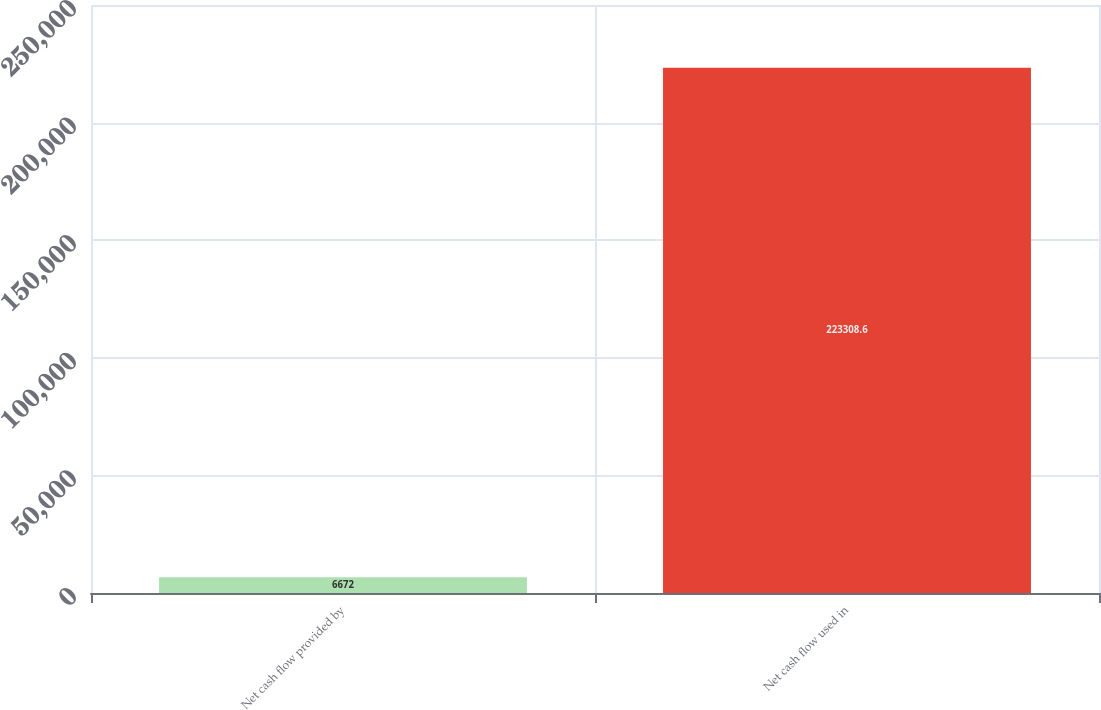<chart> <loc_0><loc_0><loc_500><loc_500><bar_chart><fcel>Net cash flow provided by<fcel>Net cash flow used in<nl><fcel>6672<fcel>223309<nl></chart> 